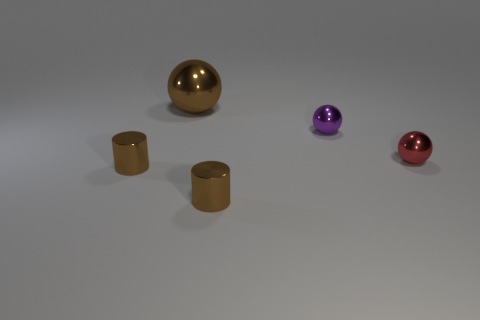What kind of lighting conditions are present in this image? The lighting seems to be soft and diffused, coming from an overhead source, causing the objects to have soft-edged shadows and subtle highlights. Does the lighting affect the colors of the objects? The lighting does impact the appearance of the colors, making them more vivid and defined, particularly noticeable on the reflective surfaces of the spheres. 